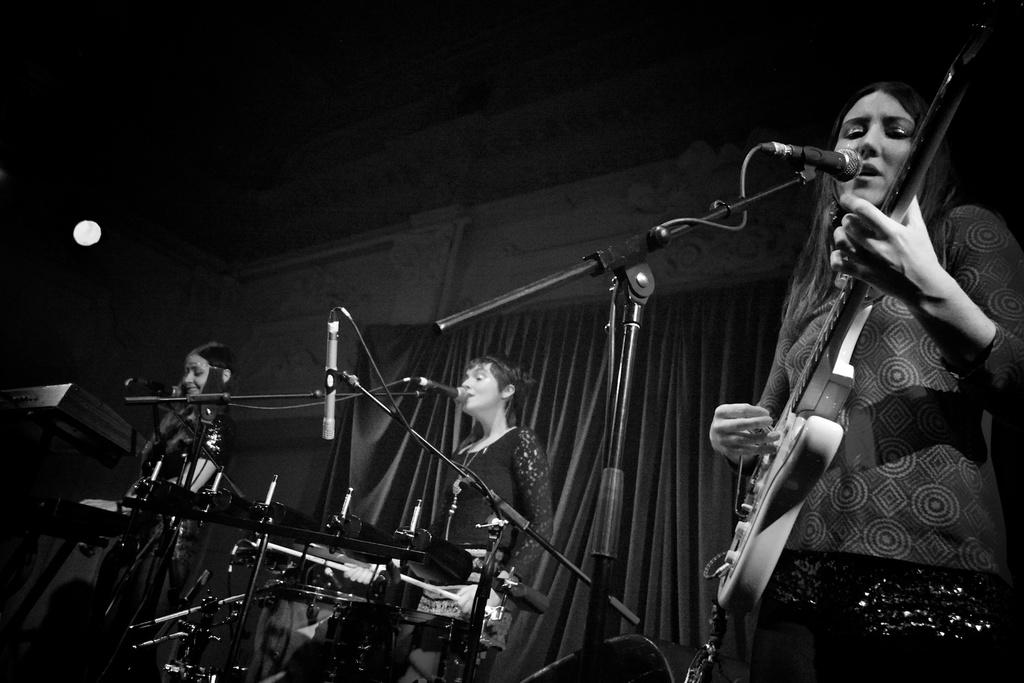How many people are in the image? There are three women in the image. What are the women doing in the image? The women are playing musical instruments. Can you describe any equipment or tools in front of the women? Yes, there is a microphone in front of the women. What type of exchange is taking place on the sidewalk in the image? There is no exchange or sidewalk present in the image; it features three women playing musical instruments with a microphone in front of them. 